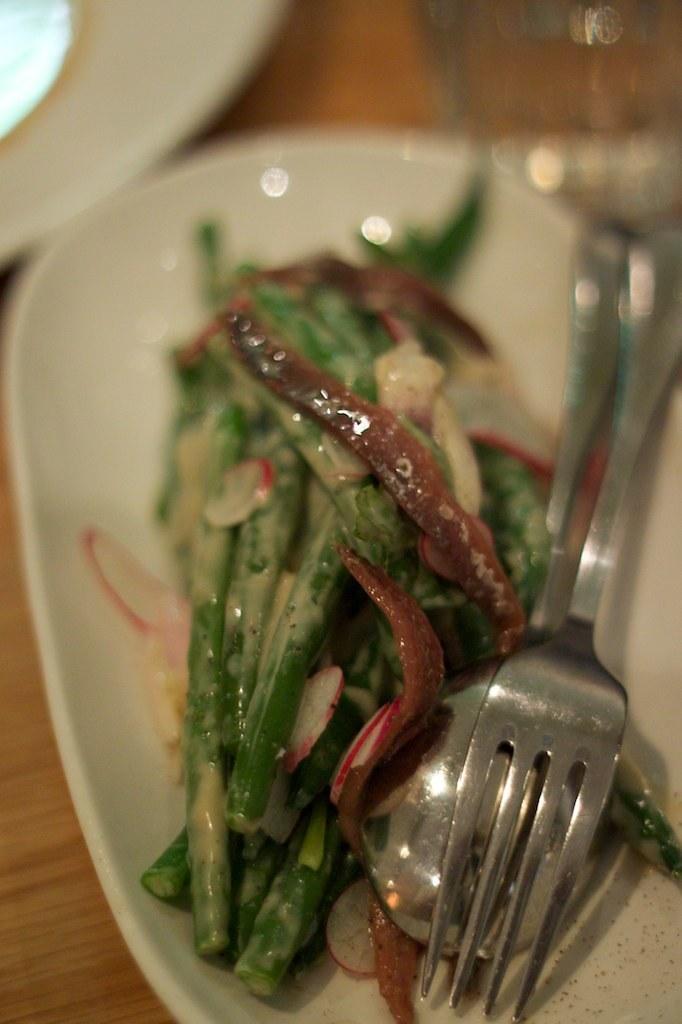Please provide a concise description of this image. On the right side it is a fork,spoon and there are food items in a white color plate. 